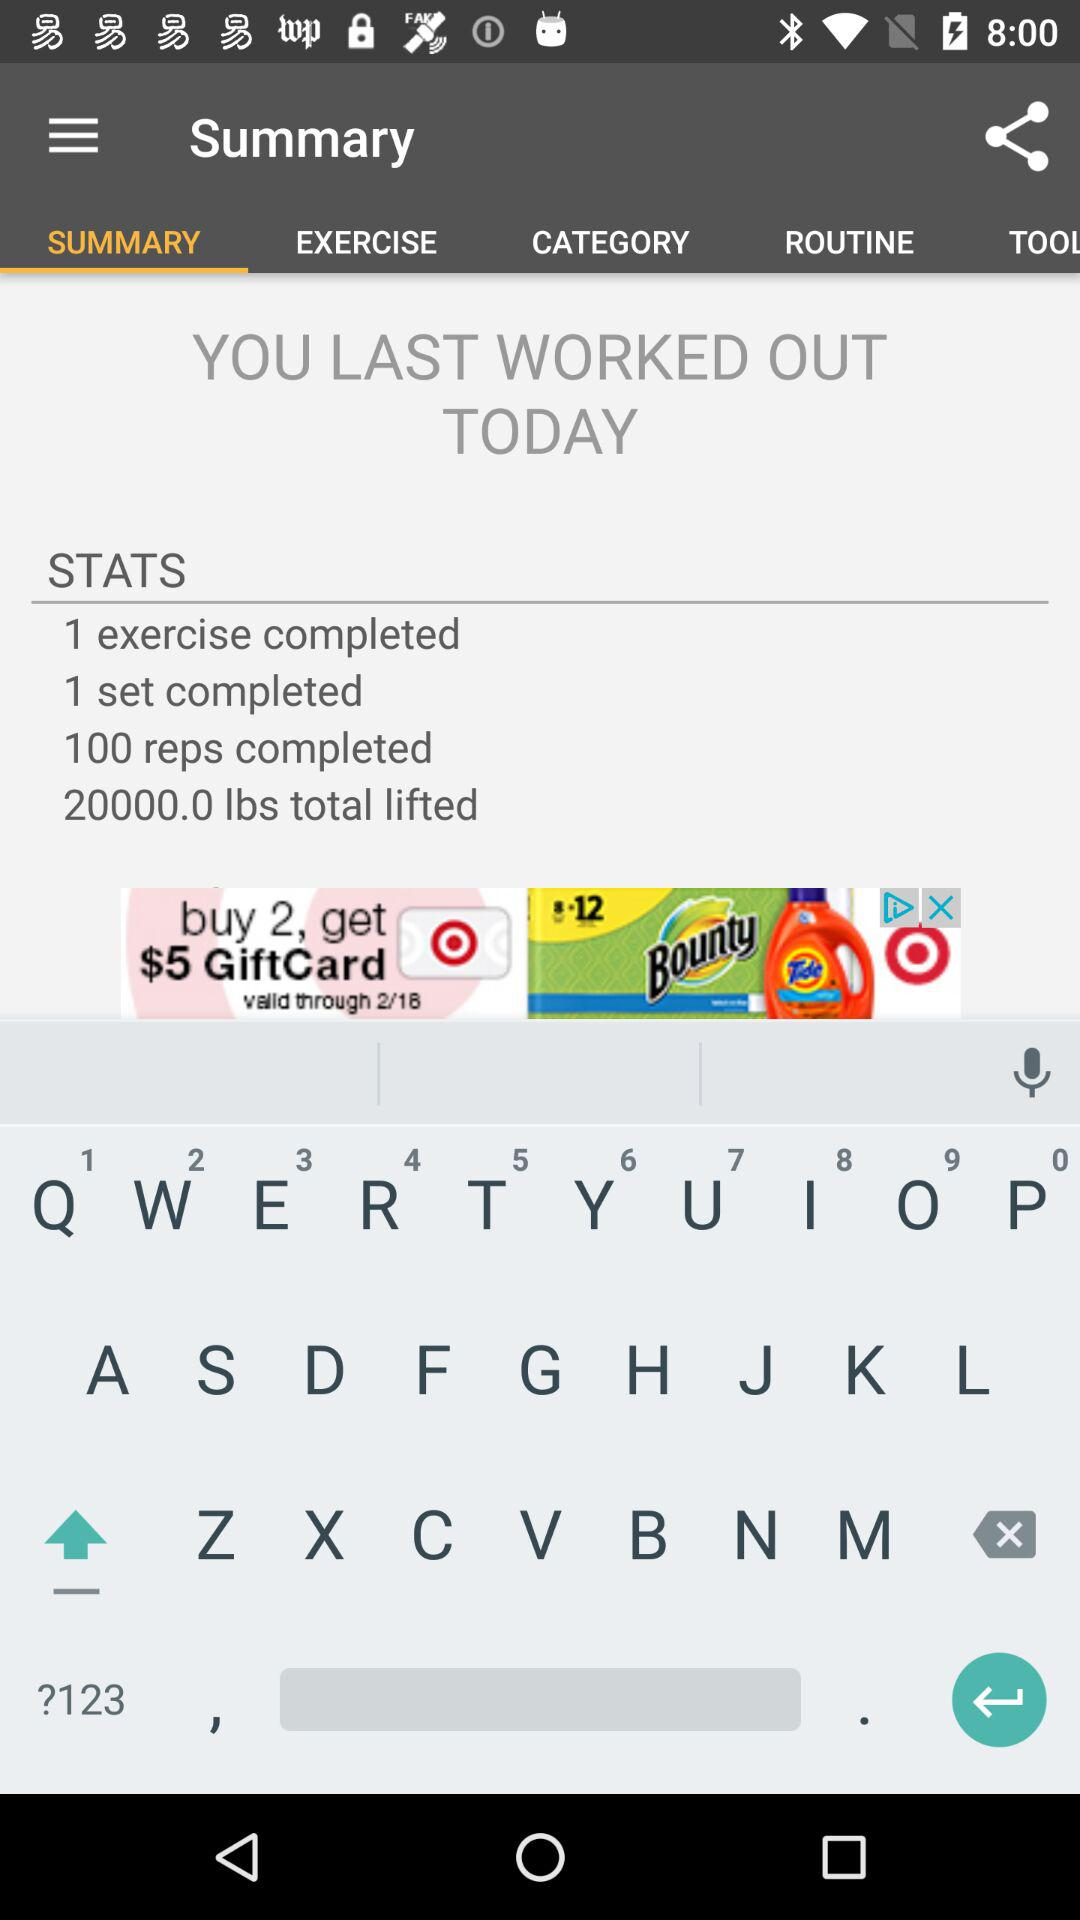Were there any goals set for the workout mentioned on the screen? The image of the workout summary does not contain any information about specific goals set for the workout. 